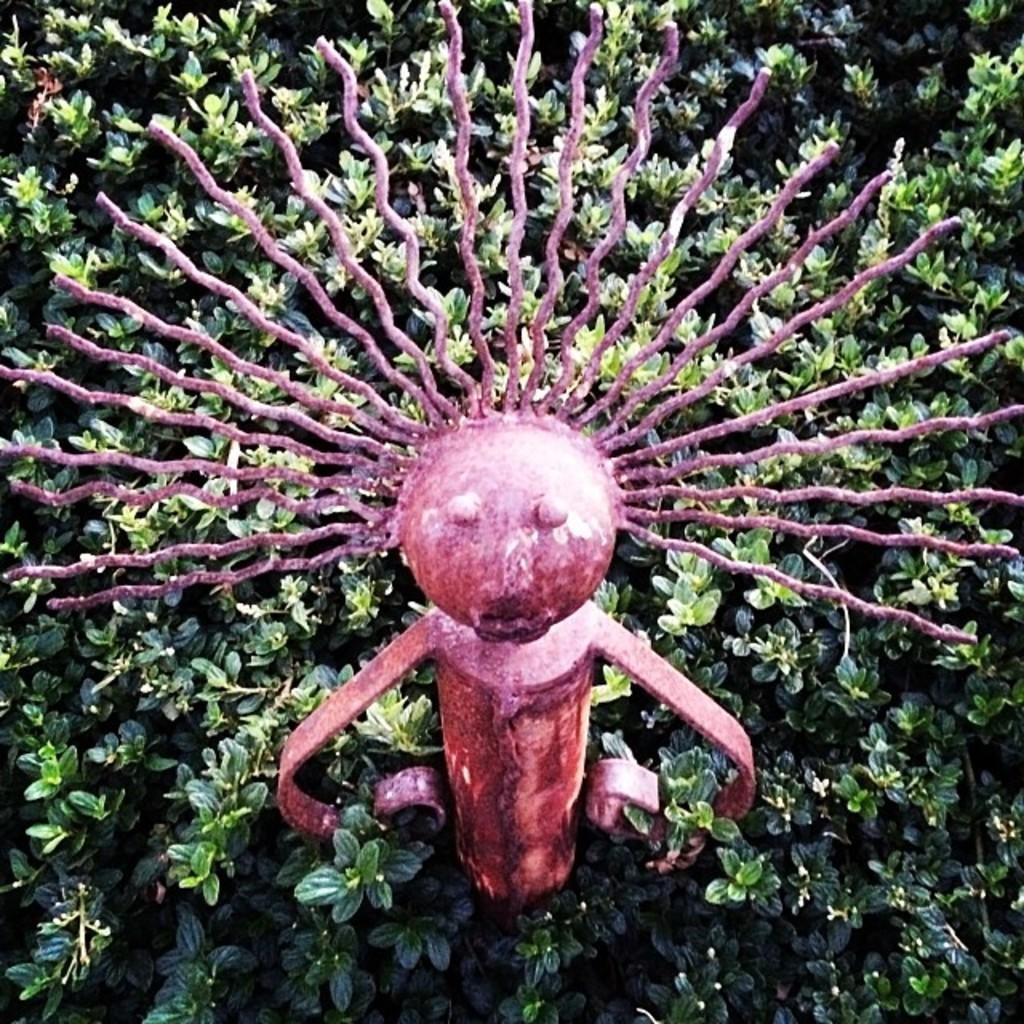What is the main subject of the image? There is a statue in the image. What material is the statue made of? The statue is made of iron. What can be seen on the ground in the image? There are plants on the ground in the image. What color are the plants? The plants are green. How is the iron statue decorated? The iron statue is painted pink. What type of songs can be heard coming from the statue in the image? There are no songs coming from the statue in the image, as it is a statue and not capable of producing sound. 